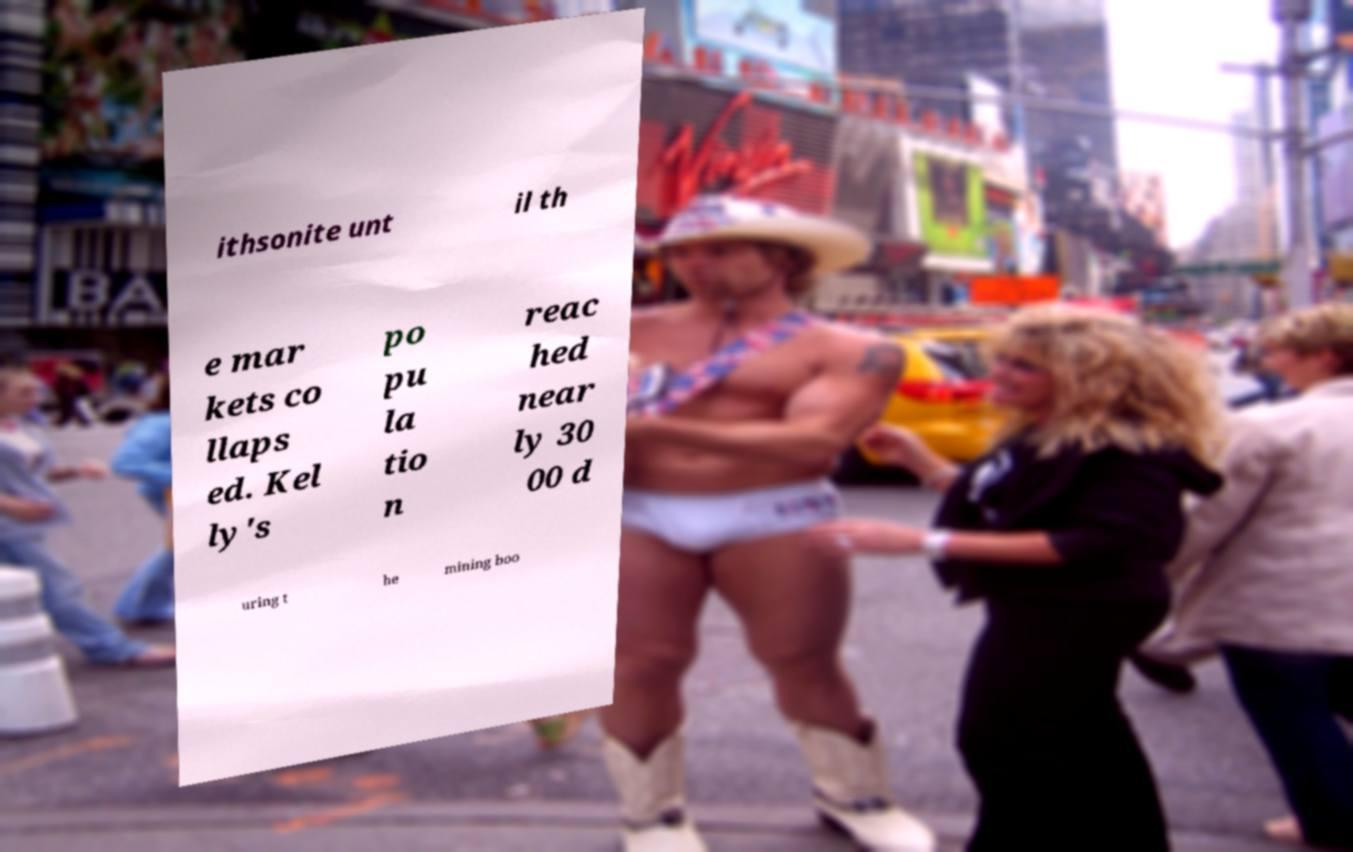Could you assist in decoding the text presented in this image and type it out clearly? ithsonite unt il th e mar kets co llaps ed. Kel ly's po pu la tio n reac hed near ly 30 00 d uring t he mining boo 